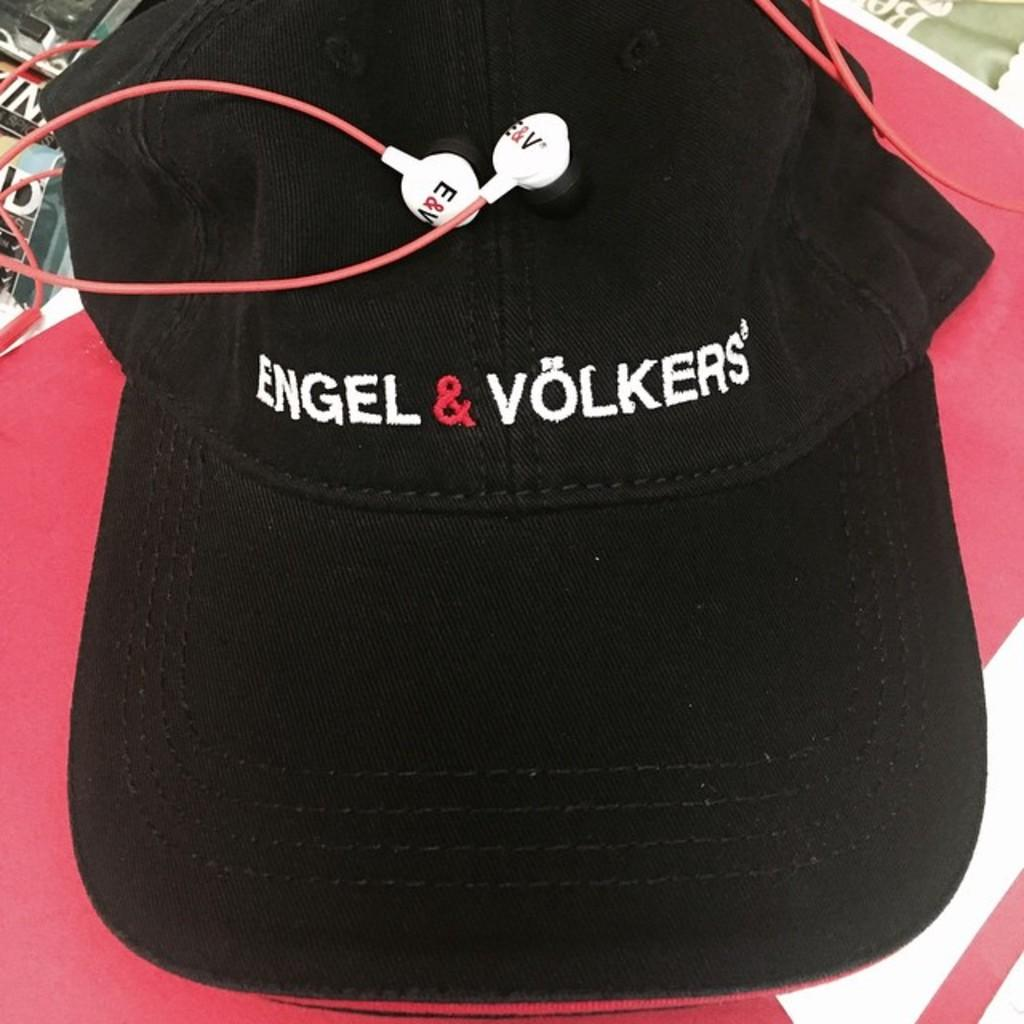What object is in the image that is typically worn on the head? There is a cap in the image. Where is the cap located in the image? The cap is placed on a table. What other object is in the image that is related to sound? There are earphones in the image. Where are the earphones located in the image? The earphones are placed on a table. What type of crown is stored in the drawer in the image? There is no crown or drawer present in the image. How many legs can be seen on the table in the image? The image does not show the legs of the table; it only shows the cap and earphones placed on the table's surface. 